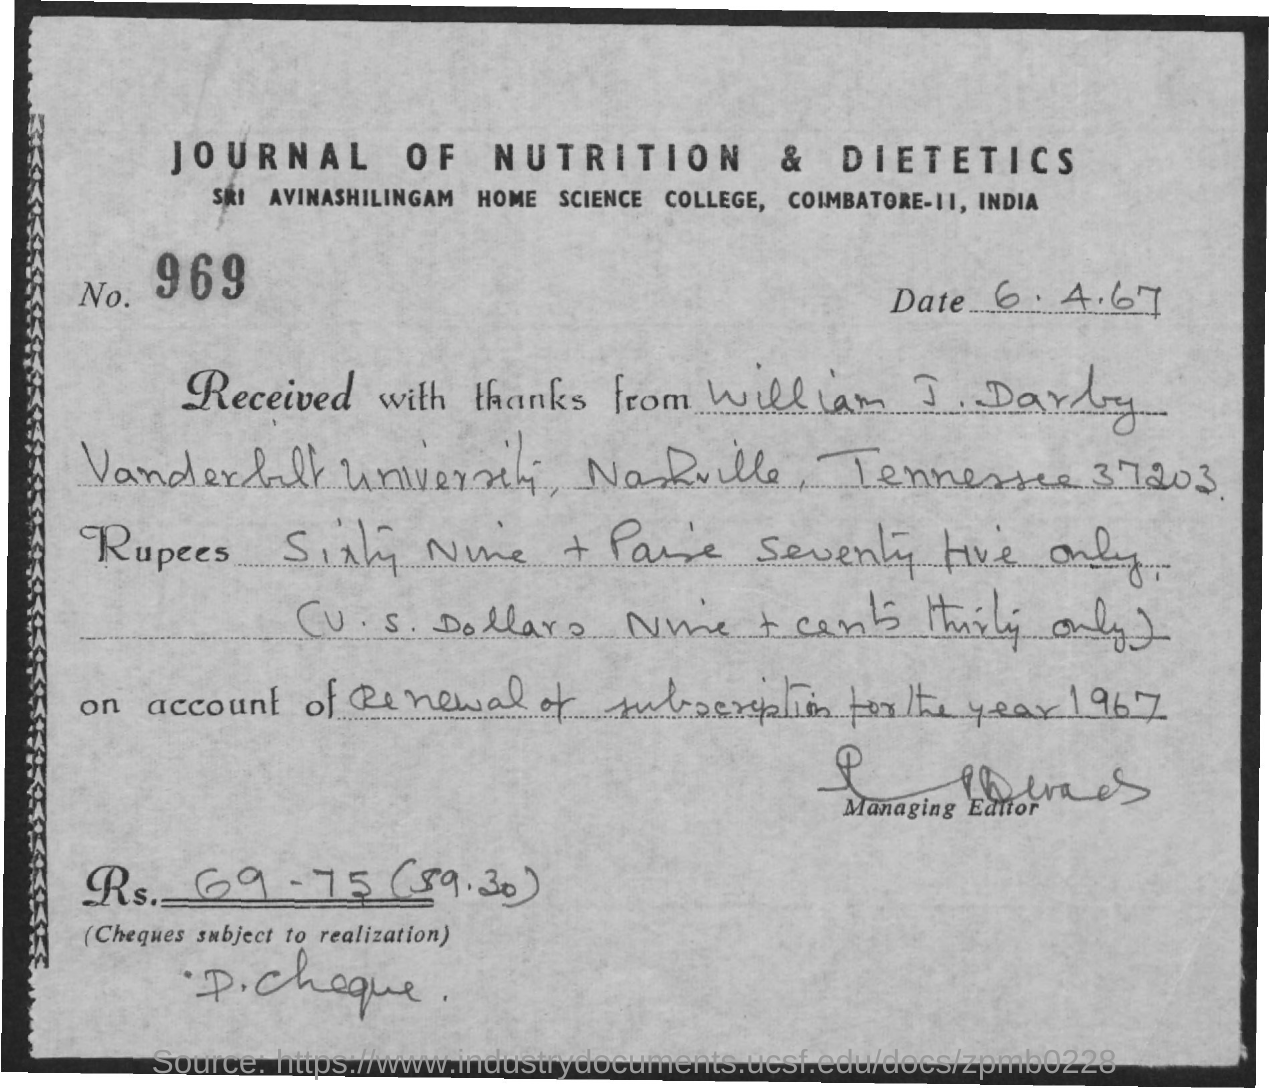Which Journal is mentioned in the header of the document?
Provide a succinct answer. JOURNAL OF NUTRITION & DIETETICS. What is the No. mentioned in the document?
Your answer should be compact. 969. What is the date mentioned in this document?
Make the answer very short. 6.4.67. What is the check amount in digits?
Provide a succinct answer. RS. 69 - 75 ($9.30). 